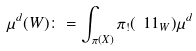Convert formula to latex. <formula><loc_0><loc_0><loc_500><loc_500>\mu ^ { d } ( W ) \colon = \int _ { \pi ( X ) } \pi _ { ! } ( \ 1 1 _ { W } ) \mu ^ { d }</formula> 